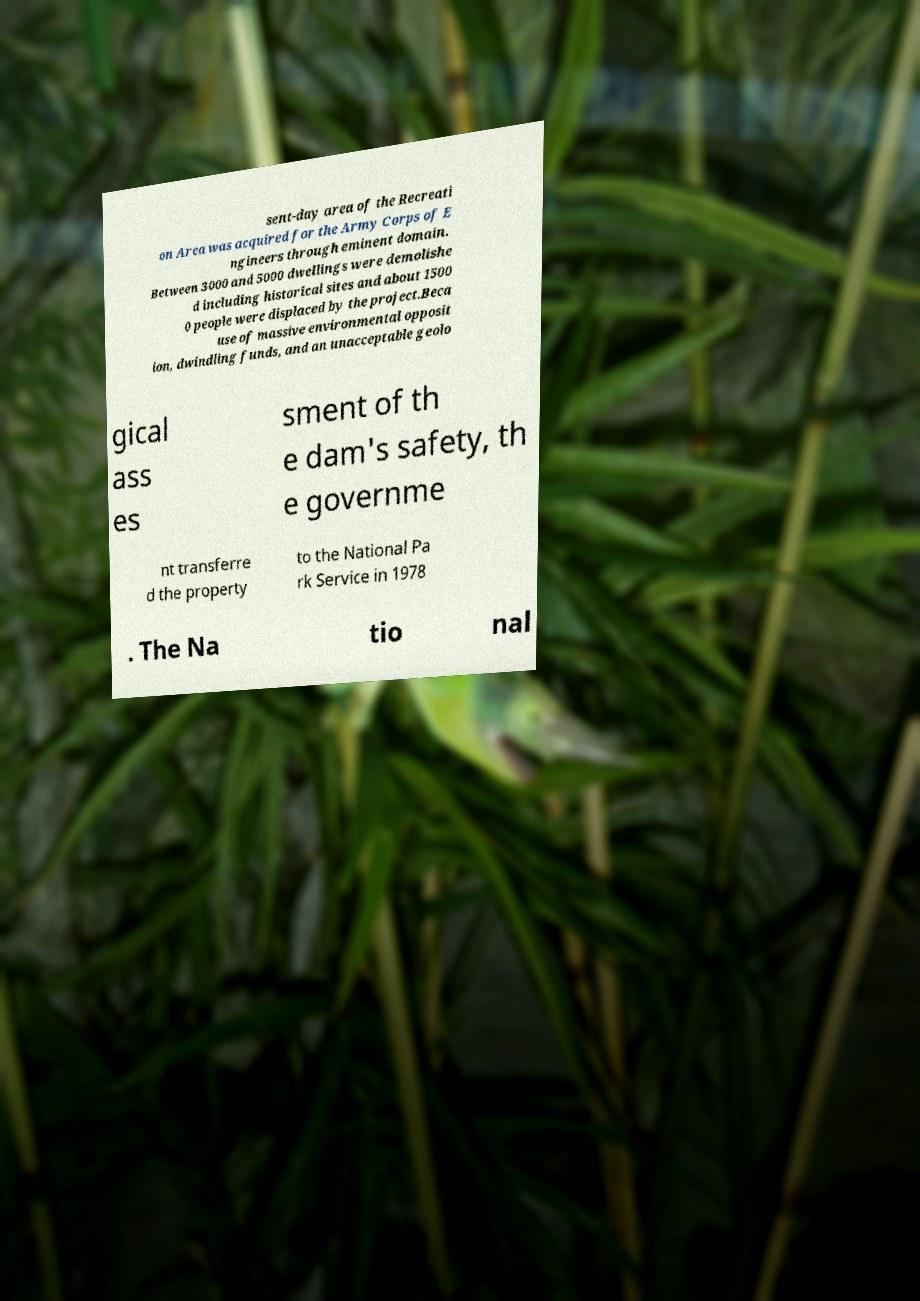I need the written content from this picture converted into text. Can you do that? sent-day area of the Recreati on Area was acquired for the Army Corps of E ngineers through eminent domain. Between 3000 and 5000 dwellings were demolishe d including historical sites and about 1500 0 people were displaced by the project.Beca use of massive environmental opposit ion, dwindling funds, and an unacceptable geolo gical ass es sment of th e dam's safety, th e governme nt transferre d the property to the National Pa rk Service in 1978 . The Na tio nal 